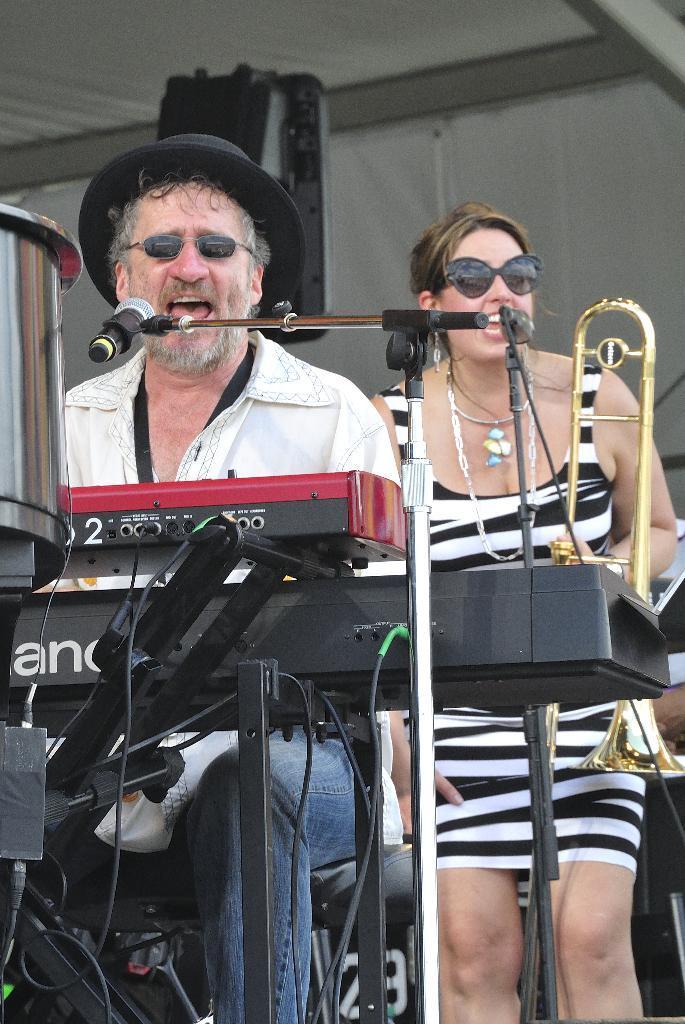In one or two sentences, can you explain what this image depicts? In this picture I can see there is a man sitting and there is a piano in front of him and there is a woman standing in the backdrop and there is a microphone stand and they are singing and are wearing glasses and the man is wearing a cap. In the backdrop there is a wall. 